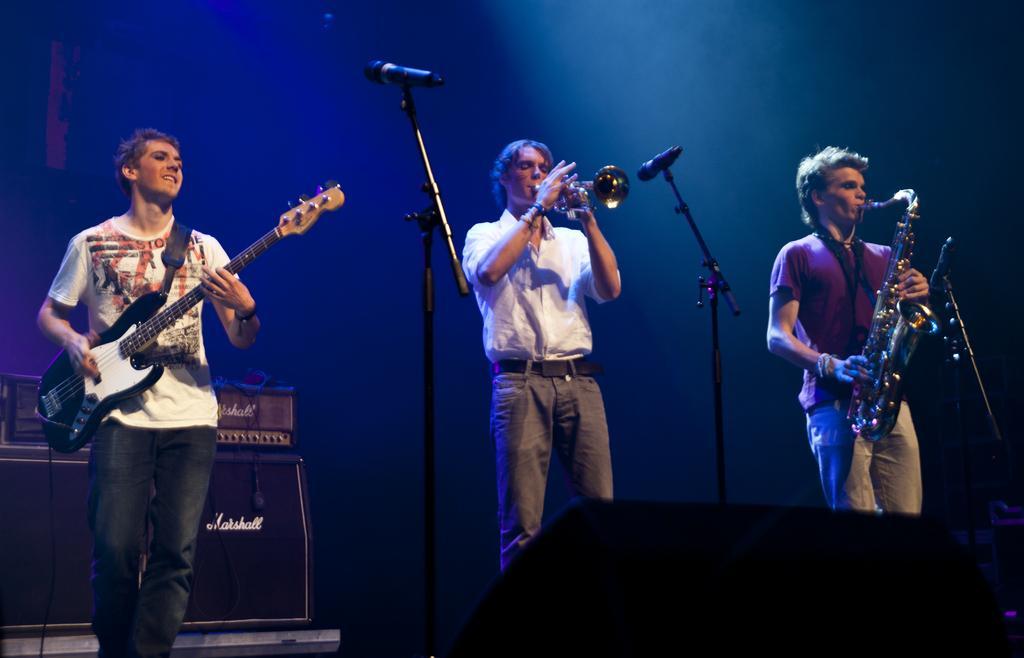Could you give a brief overview of what you see in this image? In this picture I can observe three members standing on the stage. Three of them are playing three different musical instruments in their hands. One of them is playing guitar and two of them are playing trumpets. I can observe mics on the stage. On the left side there is a speaker. The background is dark. 